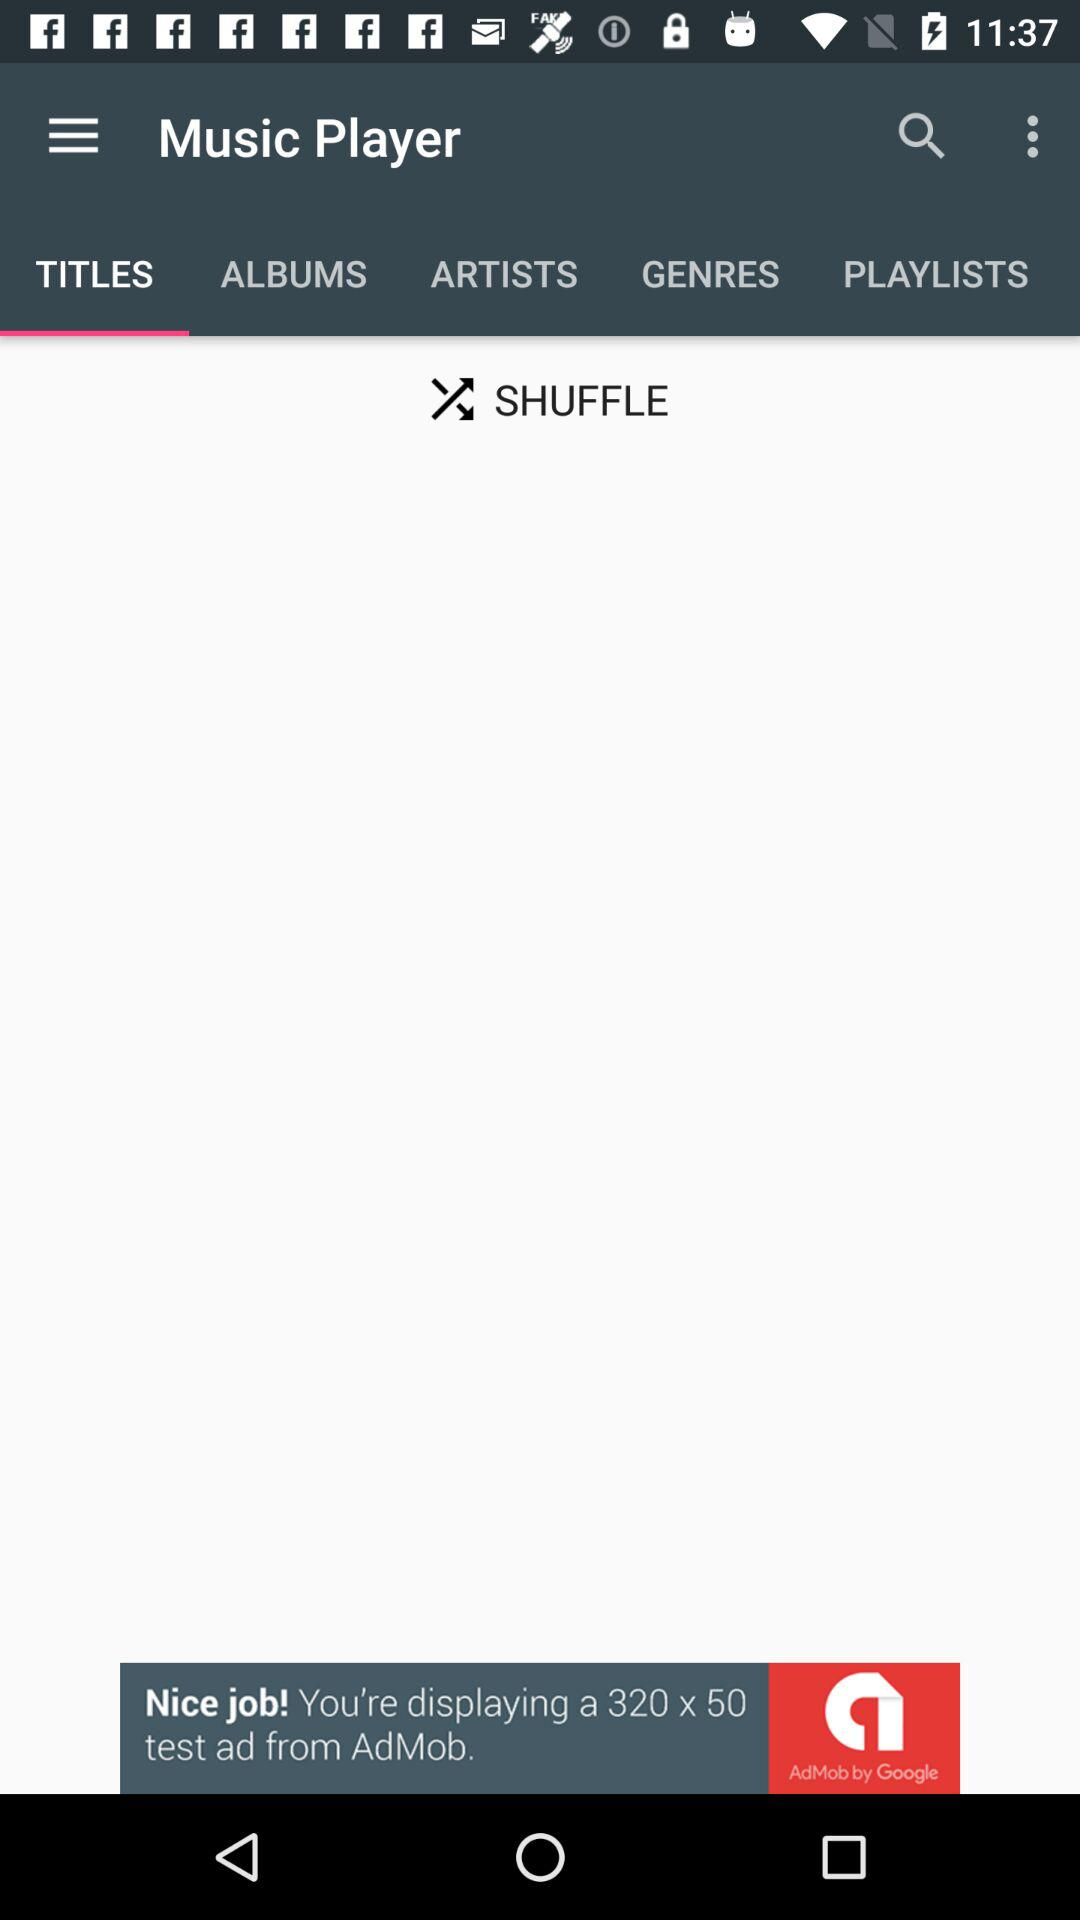Which titles are available?
When the provided information is insufficient, respond with <no answer>. <no answer> 